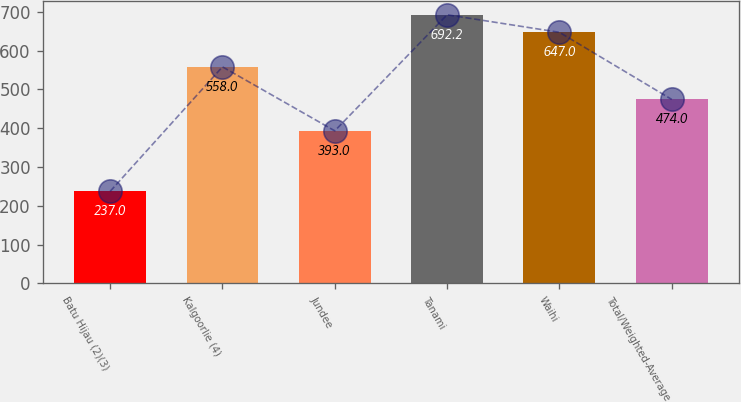<chart> <loc_0><loc_0><loc_500><loc_500><bar_chart><fcel>Batu Hijau (2)(3)<fcel>Kalgoorlie (4)<fcel>Jundee<fcel>Tanami<fcel>Waihi<fcel>Total/Weighted-Average<nl><fcel>237<fcel>558<fcel>393<fcel>692.2<fcel>647<fcel>474<nl></chart> 